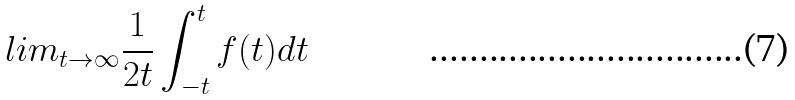<formula> <loc_0><loc_0><loc_500><loc_500>l i m _ { t \rightarrow \infty } \frac { 1 } { 2 t } \int _ { - t } ^ { t } f ( t ) d t</formula> 